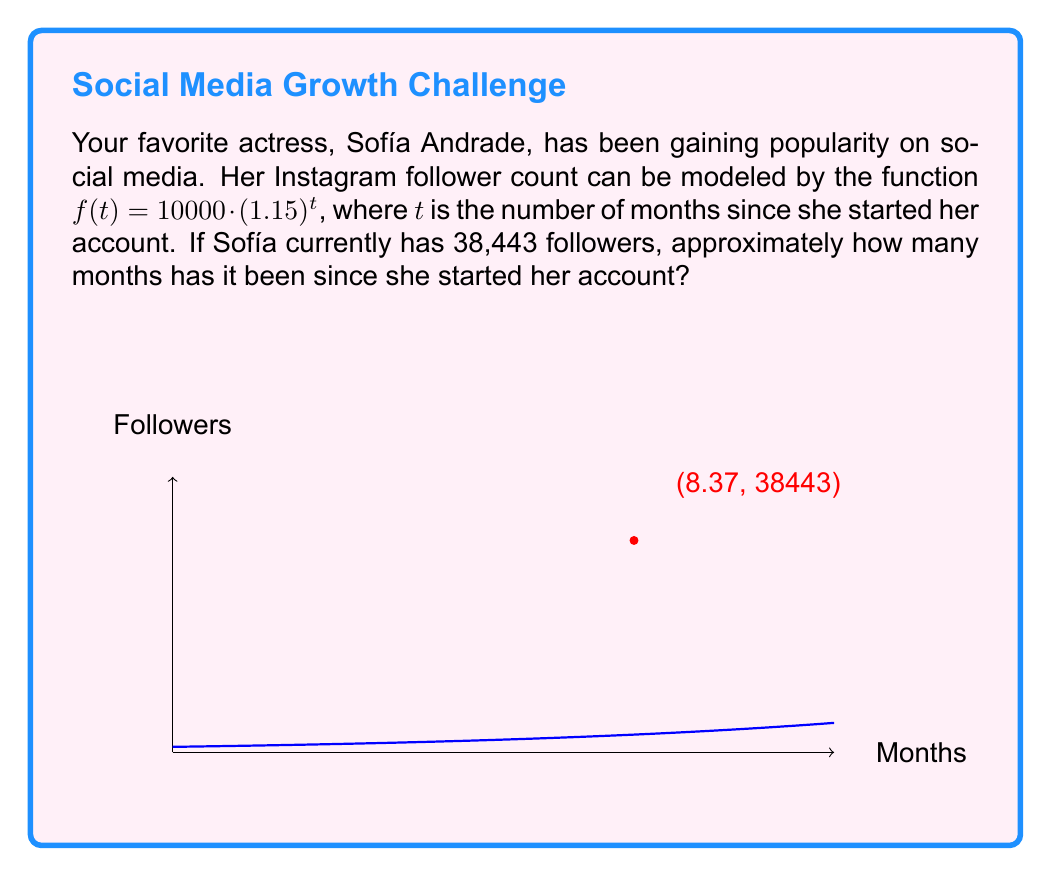Could you help me with this problem? Let's approach this step-by-step:

1) We're given the function $f(t) = 10000 \cdot (1.15)^t$, where $f(t)$ represents the number of followers and $t$ is the number of months.

2) We know that Sofía currently has 38,443 followers. So we can set up the equation:

   $38443 = 10000 \cdot (1.15)^t$

3) To solve for $t$, we first divide both sides by 10000:

   $3.8443 = (1.15)^t$

4) Now we can take the natural logarithm of both sides:

   $\ln(3.8443) = \ln((1.15)^t)$

5) Using the logarithm property $\ln(a^b) = b\ln(a)$, we get:

   $\ln(3.8443) = t \cdot \ln(1.15)$

6) Now we can solve for $t$:

   $t = \frac{\ln(3.8443)}{\ln(1.15)}$

7) Using a calculator:

   $t \approx \frac{1.3464}{0.1398} \approx 8.37$

Therefore, it has been approximately 8.37 months since Sofía started her account.
Answer: 8.37 months 